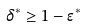Convert formula to latex. <formula><loc_0><loc_0><loc_500><loc_500>\delta ^ { * } \geq 1 - \epsilon ^ { * }</formula> 